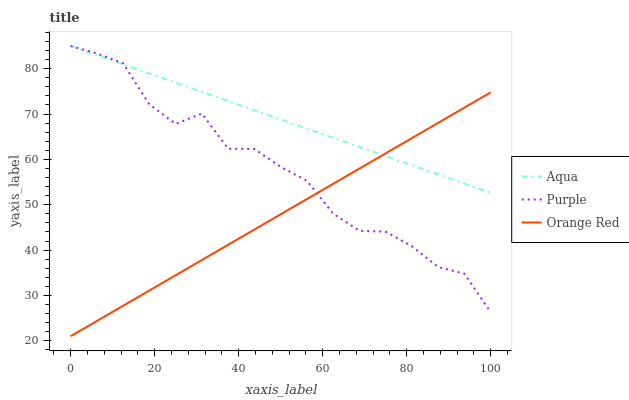Does Aqua have the minimum area under the curve?
Answer yes or no. No. Does Orange Red have the maximum area under the curve?
Answer yes or no. No. Is Aqua the smoothest?
Answer yes or no. No. Is Aqua the roughest?
Answer yes or no. No. Does Aqua have the lowest value?
Answer yes or no. No. Does Orange Red have the highest value?
Answer yes or no. No. 